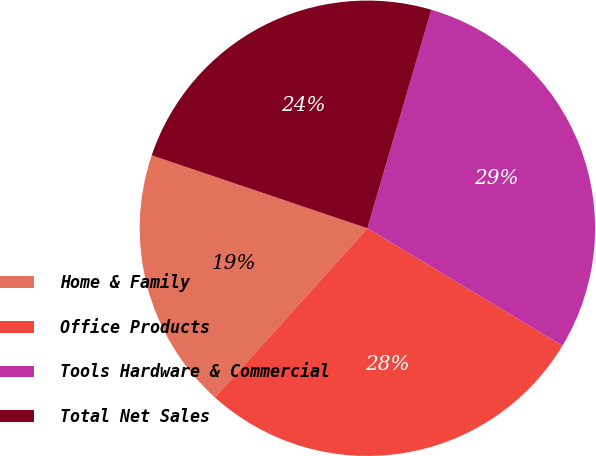Convert chart. <chart><loc_0><loc_0><loc_500><loc_500><pie_chart><fcel>Home & Family<fcel>Office Products<fcel>Tools Hardware & Commercial<fcel>Total Net Sales<nl><fcel>18.52%<fcel>28.05%<fcel>29.09%<fcel>24.34%<nl></chart> 